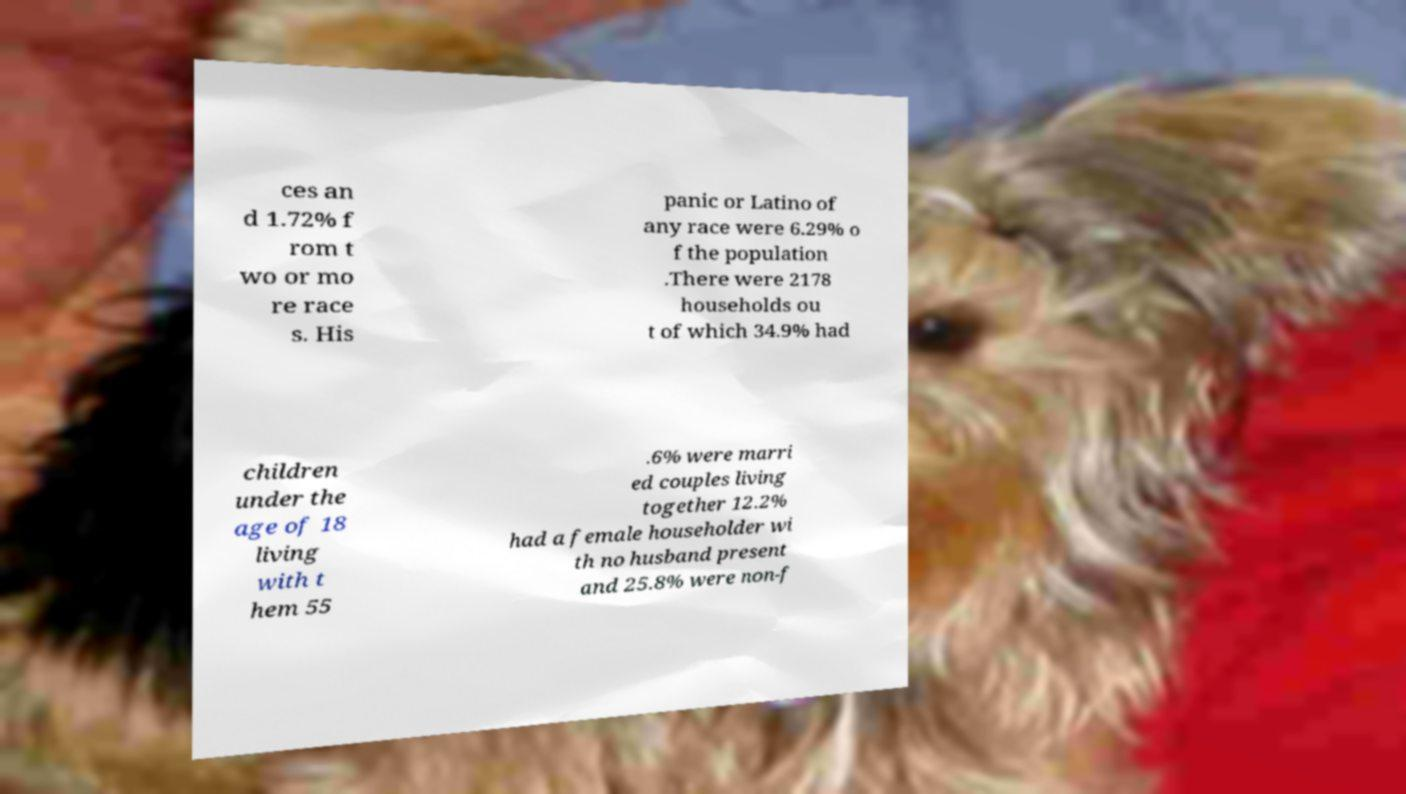What messages or text are displayed in this image? I need them in a readable, typed format. ces an d 1.72% f rom t wo or mo re race s. His panic or Latino of any race were 6.29% o f the population .There were 2178 households ou t of which 34.9% had children under the age of 18 living with t hem 55 .6% were marri ed couples living together 12.2% had a female householder wi th no husband present and 25.8% were non-f 